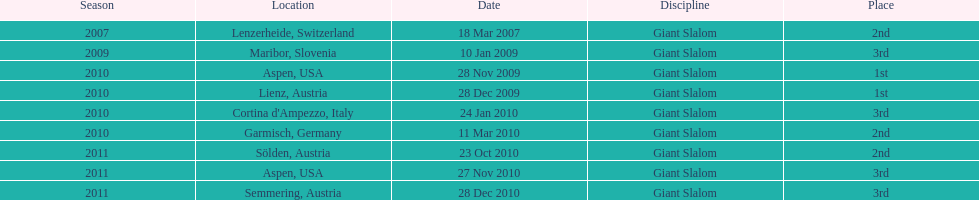The final race finishing place was not 1st but what other place? 3rd. 